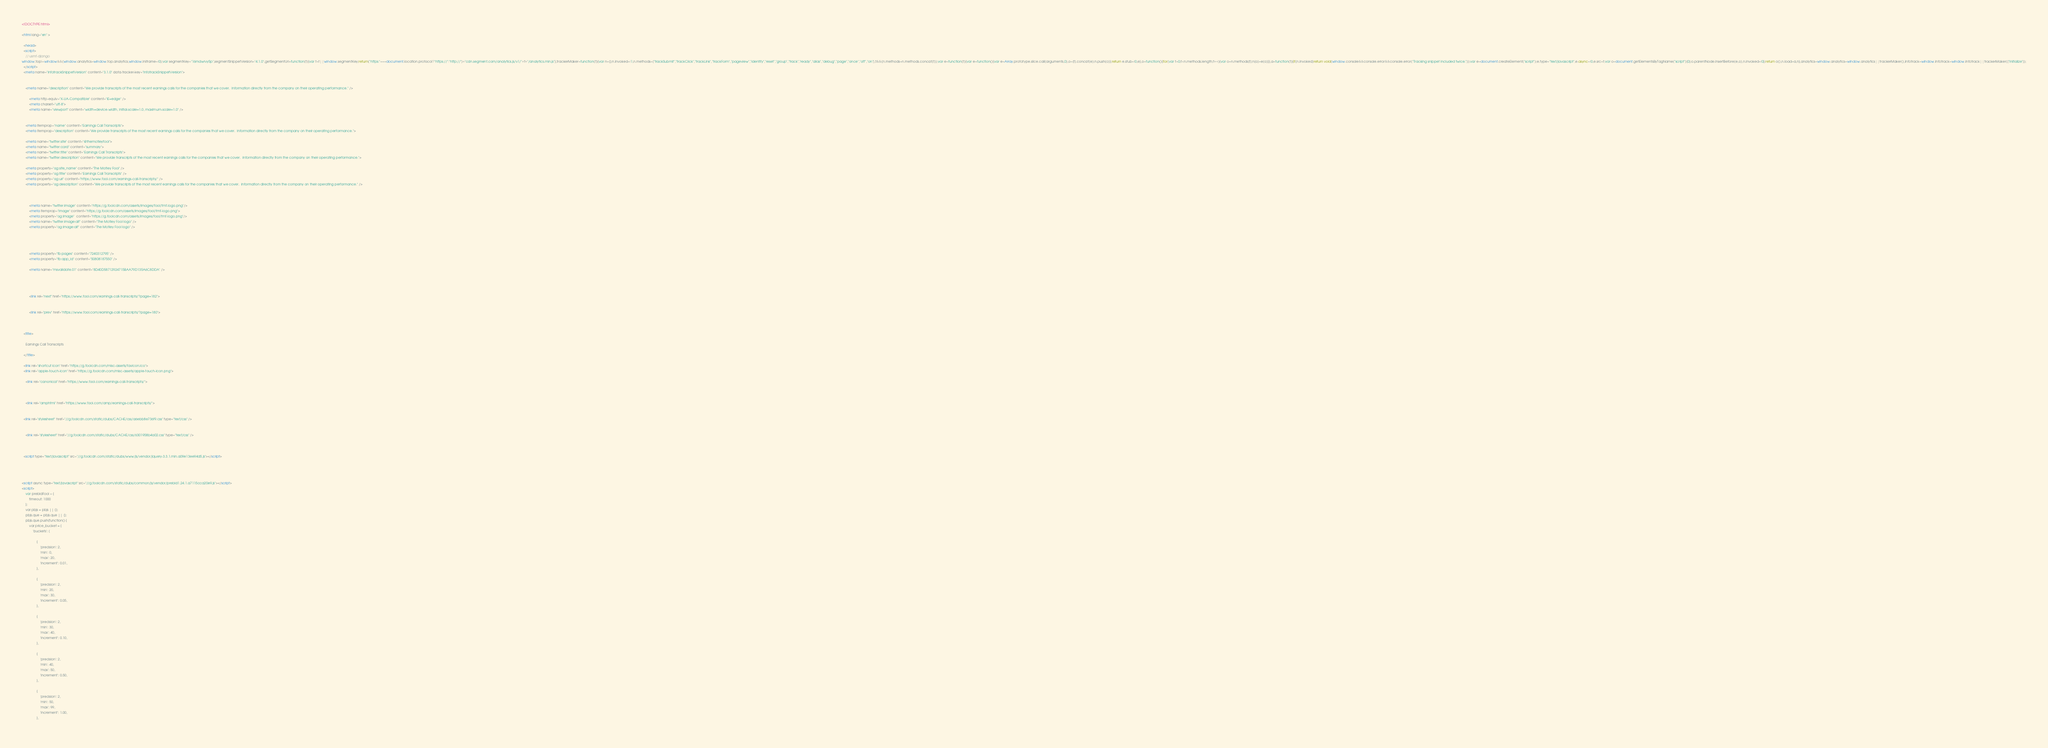<code> <loc_0><loc_0><loc_500><loc_500><_HTML_>

<!DOCTYPE html>

<html lang="en" >

  <head>
  <script>
    // usmf-django
window.top!=window&&(window.analytics=window.top.analytics,window.inIframe=!0);var segmentKey="16mdwrvy5p",segmentSnippetVersion="4.1.0",getSegmentUrl=function(t){var t=t||window.segmentKey;return("https:"===document.location.protocol?"https://":"http://")+"cdn.segment.com/analytics.js/v1/"+t+"/analytics.min.js"},trackerMaker=function(t){var n=[];n.invoked=!1,n.methods=["trackSubmit","trackClick","trackLink","trackForm","pageview","identify","reset","group","track","ready","alias","debug","page","once","off","on"],t&&(n.methods=n.methods.concat(t));var e=function(t){var e=function(){var e=Array.prototype.slice.call(arguments,0),o=[t].concat(e);n.push(o)};return e.stub=!0,e},o=function(){for(var t=0;t<n.methods.length;t++){var o=n.methods[t];n[o]=e(o)}},a=function(t){if(n.invoked)return void(window.console&&console.error&&console.error("Tracking snippet included twice."));var e=document.createElement("script");e.type="text/javascript",e.async=!0,e.src=t;var o=document.getElementsByTagName("script")[0];o.parentNode.insertBefore(e,o),n.invoked=!0};return o(),n.load=a,n},analytics=window.analytics=window.analytics||trackerMaker(),Infotrack=window.Infotrack=window.Infotrack||trackerMaker(["initialize"]);
  </script>
  <meta name="infotrackSnippetVersion" content="3.1.0" data-tracker-key="infotrackSnippetVersion">
    
        
    <meta name="description" content="We provide transcripts of the most recent earnings calls for the companies that we cover.  Information directly from the company on their operating performance." />

        <meta http-equiv="X-UA-Compatible" content="IE=edge" />
        <meta charset="utf-8">
        <meta name="viewport" content="width=device-width, initial-scale=1.0, maximum-scale=1.0" />

        
    <meta itemprop="name" content="Earnings Call Transcripts">
    <meta itemprop="description" content="We provide transcripts of the most recent earnings calls for the companies that we cover.  Information directly from the company on their operating performance.">

    <meta name="twitter:site" content="@themotleyfool">
    <meta name="twitter:card" content="summary">
    <meta name="twitter:title" content="Earnings Call Transcripts">
    <meta name="twitter:description" content="We provide transcripts of the most recent earnings calls for the companies that we cover.  Information directly from the company on their operating performance.">

    <meta property="og:site_name" content="The Motley Fool" />
    <meta property="og:title" content="Earnings Call Transcripts" />
    <meta property="og:url" content="https://www.fool.com/earnings-call-transcripts/" />
    <meta property="og:description" content="We provide transcripts of the most recent earnings calls for the companies that we cover.  Information directly from the company on their operating performance." />

    
    
        <meta name="twitter:image" content="https://g.foolcdn.com/assets/images/fool/tmf-logo.png"/>
        <meta itemprop="image" content="https://g.foolcdn.com/assets/images/fool/tmf-logo.png">
        <meta property="og:image"  content="https://g.foolcdn.com/assets/images/fool/tmf-logo.png"/>
        <meta name="twitter:image:alt" content="The Motley Fool logo" />
        <meta property="og:image:alt" content="The Motley Fool logo" />
    
    


        <meta property="fb:pages" content="7240312795" />
        <meta property="fb:app_id" content="50808187550" />

        <meta name="msvalidate.01" content="8D40D58712924715BAA79D135A6C8DDA" />
    

    
    
        <link rel="next" href="https://www.fool.com/earnings-call-transcripts/?page=182">
    
    
        <link rel="prev" href="https://www.fool.com/earnings-call-transcripts/?page=180">
    


  <title>
      
    Earnings Call Transcripts

  </title>

  <link rel="shortcut icon" href="https://g.foolcdn.com/misc-assets/favicon.ico">
  <link rel="apple-touch-icon" href="https://g.foolcdn.com/misc-assets/apple-touch-icon.png">
  
    <link rel="canonical" href="https://www.fool.com/earnings-call-transcripts/">


  
    <link rel="amphtml" href="https://www.fool.com/amp/earnings-call-transcripts/">


  <link rel="stylesheet" href="//g.foolcdn.com/static/dubs/CACHE/css/a6ebb8e736f9.css" type="text/css" />

  
    <link rel="stylesheet" href="//g.foolcdn.com/static/dubs/CACHE/css/6301958b4a02.css" type="text/css" />


  
  <script type="text/javascript" src="//g.foolcdn.com/static/dubs/www/js/vendor/jquery-3.3.1.min.a09e13ee94d5.js"></script>

  
  
    
<script async type="text/javascript" src="//g.foolcdn.com/static/dubs/common/js/vendor/prebid1.24.1.a7115cca20e9.js"></script>
<script>
    var prebidFool = {
        timeout: 1000
    };
    var pbjs = pbjs || {};
    pbjs.que = pbjs.que || [];
    pbjs.que.push(function() {
        var price_bucket = {
            'buckets': [
                
                {
                    'precision': 2,
                    'min': 0,
                    'max': 20,
                    'increment': 0.01,
                },
                
                {
                    'precision': 2,
                    'min': 20,
                    'max': 30,
                    'increment': 0.05,
                },
                
                {
                    'precision': 2,
                    'min': 30,
                    'max': 40,
                    'increment': 0.10,
                },
                
                {
                    'precision': 2,
                    'min': 40,
                    'max': 50,
                    'increment': 0.50,
                },
                
                {
                    'precision': 2,
                    'min': 50,
                    'max': 99,
                    'increment': 1.00,
                },
                </code> 